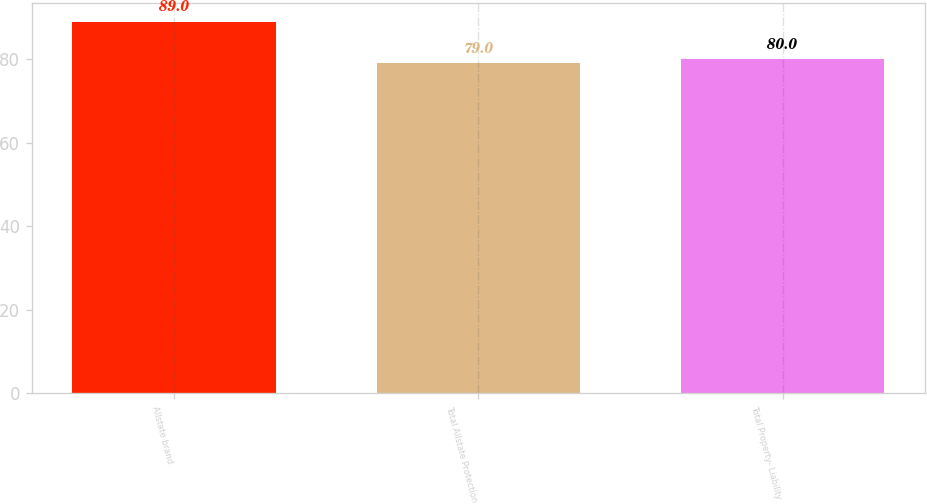Convert chart to OTSL. <chart><loc_0><loc_0><loc_500><loc_500><bar_chart><fcel>Allstate brand<fcel>Total Allstate Protection<fcel>Total Property- Liability<nl><fcel>89<fcel>79<fcel>80<nl></chart> 